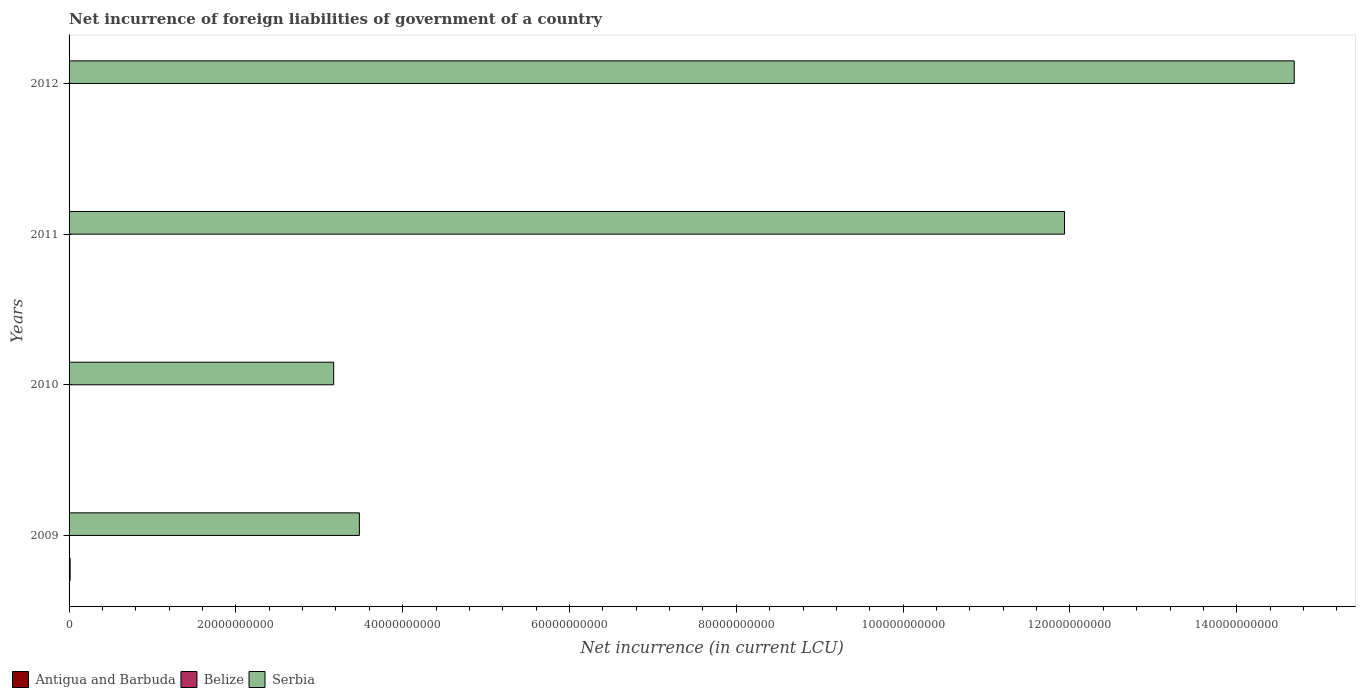How many groups of bars are there?
Your answer should be very brief. 4. Are the number of bars per tick equal to the number of legend labels?
Ensure brevity in your answer.  No. Are the number of bars on each tick of the Y-axis equal?
Ensure brevity in your answer.  No. How many bars are there on the 2nd tick from the bottom?
Keep it short and to the point. 2. What is the net incurrence of foreign liabilities in Antigua and Barbuda in 2009?
Ensure brevity in your answer.  1.27e+08. Across all years, what is the maximum net incurrence of foreign liabilities in Serbia?
Offer a very short reply. 1.47e+11. Across all years, what is the minimum net incurrence of foreign liabilities in Serbia?
Offer a terse response. 3.17e+1. In which year was the net incurrence of foreign liabilities in Serbia maximum?
Your answer should be compact. 2012. What is the total net incurrence of foreign liabilities in Belize in the graph?
Keep it short and to the point. 8.49e+07. What is the difference between the net incurrence of foreign liabilities in Belize in 2009 and that in 2012?
Provide a short and direct response. -2.57e+07. What is the difference between the net incurrence of foreign liabilities in Serbia in 2009 and the net incurrence of foreign liabilities in Antigua and Barbuda in 2011?
Keep it short and to the point. 3.48e+1. What is the average net incurrence of foreign liabilities in Belize per year?
Offer a terse response. 2.12e+07. In the year 2009, what is the difference between the net incurrence of foreign liabilities in Antigua and Barbuda and net incurrence of foreign liabilities in Belize?
Your answer should be very brief. 1.12e+08. What is the ratio of the net incurrence of foreign liabilities in Serbia in 2009 to that in 2012?
Your answer should be compact. 0.24. Is the net incurrence of foreign liabilities in Serbia in 2009 less than that in 2011?
Make the answer very short. Yes. What is the difference between the highest and the second highest net incurrence of foreign liabilities in Belize?
Your answer should be compact. 1.61e+07. What is the difference between the highest and the lowest net incurrence of foreign liabilities in Serbia?
Give a very brief answer. 1.15e+11. Is the sum of the net incurrence of foreign liabilities in Serbia in 2009 and 2012 greater than the maximum net incurrence of foreign liabilities in Antigua and Barbuda across all years?
Your answer should be very brief. Yes. Is it the case that in every year, the sum of the net incurrence of foreign liabilities in Antigua and Barbuda and net incurrence of foreign liabilities in Belize is greater than the net incurrence of foreign liabilities in Serbia?
Your response must be concise. No. What is the difference between two consecutive major ticks on the X-axis?
Offer a very short reply. 2.00e+1. Does the graph contain any zero values?
Provide a succinct answer. Yes. Where does the legend appear in the graph?
Your response must be concise. Bottom left. What is the title of the graph?
Your answer should be compact. Net incurrence of foreign liabilities of government of a country. Does "Sudan" appear as one of the legend labels in the graph?
Offer a terse response. No. What is the label or title of the X-axis?
Offer a very short reply. Net incurrence (in current LCU). What is the label or title of the Y-axis?
Your response must be concise. Years. What is the Net incurrence (in current LCU) of Antigua and Barbuda in 2009?
Provide a short and direct response. 1.27e+08. What is the Net incurrence (in current LCU) of Belize in 2009?
Offer a very short reply. 1.56e+07. What is the Net incurrence (in current LCU) in Serbia in 2009?
Provide a short and direct response. 3.48e+1. What is the Net incurrence (in current LCU) in Antigua and Barbuda in 2010?
Give a very brief answer. 0. What is the Net incurrence (in current LCU) in Belize in 2010?
Keep it short and to the point. 2.74e+06. What is the Net incurrence (in current LCU) of Serbia in 2010?
Offer a terse response. 3.17e+1. What is the Net incurrence (in current LCU) of Antigua and Barbuda in 2011?
Give a very brief answer. 3.81e+07. What is the Net incurrence (in current LCU) in Belize in 2011?
Offer a terse response. 2.52e+07. What is the Net incurrence (in current LCU) in Serbia in 2011?
Offer a very short reply. 1.19e+11. What is the Net incurrence (in current LCU) of Antigua and Barbuda in 2012?
Give a very brief answer. 0. What is the Net incurrence (in current LCU) in Belize in 2012?
Your response must be concise. 4.13e+07. What is the Net incurrence (in current LCU) of Serbia in 2012?
Keep it short and to the point. 1.47e+11. Across all years, what is the maximum Net incurrence (in current LCU) in Antigua and Barbuda?
Make the answer very short. 1.27e+08. Across all years, what is the maximum Net incurrence (in current LCU) of Belize?
Keep it short and to the point. 4.13e+07. Across all years, what is the maximum Net incurrence (in current LCU) in Serbia?
Provide a succinct answer. 1.47e+11. Across all years, what is the minimum Net incurrence (in current LCU) of Belize?
Your answer should be compact. 2.74e+06. Across all years, what is the minimum Net incurrence (in current LCU) of Serbia?
Your response must be concise. 3.17e+1. What is the total Net incurrence (in current LCU) of Antigua and Barbuda in the graph?
Your answer should be compact. 1.65e+08. What is the total Net incurrence (in current LCU) in Belize in the graph?
Provide a short and direct response. 8.49e+07. What is the total Net incurrence (in current LCU) in Serbia in the graph?
Make the answer very short. 3.33e+11. What is the difference between the Net incurrence (in current LCU) of Belize in 2009 and that in 2010?
Provide a short and direct response. 1.29e+07. What is the difference between the Net incurrence (in current LCU) of Serbia in 2009 and that in 2010?
Make the answer very short. 3.08e+09. What is the difference between the Net incurrence (in current LCU) of Antigua and Barbuda in 2009 and that in 2011?
Your response must be concise. 8.92e+07. What is the difference between the Net incurrence (in current LCU) in Belize in 2009 and that in 2011?
Keep it short and to the point. -9.60e+06. What is the difference between the Net incurrence (in current LCU) of Serbia in 2009 and that in 2011?
Make the answer very short. -8.45e+1. What is the difference between the Net incurrence (in current LCU) in Belize in 2009 and that in 2012?
Offer a very short reply. -2.57e+07. What is the difference between the Net incurrence (in current LCU) in Serbia in 2009 and that in 2012?
Provide a succinct answer. -1.12e+11. What is the difference between the Net incurrence (in current LCU) of Belize in 2010 and that in 2011?
Make the answer very short. -2.25e+07. What is the difference between the Net incurrence (in current LCU) of Serbia in 2010 and that in 2011?
Ensure brevity in your answer.  -8.76e+1. What is the difference between the Net incurrence (in current LCU) of Belize in 2010 and that in 2012?
Keep it short and to the point. -3.86e+07. What is the difference between the Net incurrence (in current LCU) in Serbia in 2010 and that in 2012?
Offer a terse response. -1.15e+11. What is the difference between the Net incurrence (in current LCU) in Belize in 2011 and that in 2012?
Make the answer very short. -1.61e+07. What is the difference between the Net incurrence (in current LCU) in Serbia in 2011 and that in 2012?
Provide a succinct answer. -2.75e+1. What is the difference between the Net incurrence (in current LCU) in Antigua and Barbuda in 2009 and the Net incurrence (in current LCU) in Belize in 2010?
Keep it short and to the point. 1.25e+08. What is the difference between the Net incurrence (in current LCU) of Antigua and Barbuda in 2009 and the Net incurrence (in current LCU) of Serbia in 2010?
Offer a very short reply. -3.16e+1. What is the difference between the Net incurrence (in current LCU) in Belize in 2009 and the Net incurrence (in current LCU) in Serbia in 2010?
Make the answer very short. -3.17e+1. What is the difference between the Net incurrence (in current LCU) of Antigua and Barbuda in 2009 and the Net incurrence (in current LCU) of Belize in 2011?
Your response must be concise. 1.02e+08. What is the difference between the Net incurrence (in current LCU) of Antigua and Barbuda in 2009 and the Net incurrence (in current LCU) of Serbia in 2011?
Your response must be concise. -1.19e+11. What is the difference between the Net incurrence (in current LCU) in Belize in 2009 and the Net incurrence (in current LCU) in Serbia in 2011?
Provide a succinct answer. -1.19e+11. What is the difference between the Net incurrence (in current LCU) of Antigua and Barbuda in 2009 and the Net incurrence (in current LCU) of Belize in 2012?
Your response must be concise. 8.60e+07. What is the difference between the Net incurrence (in current LCU) of Antigua and Barbuda in 2009 and the Net incurrence (in current LCU) of Serbia in 2012?
Provide a short and direct response. -1.47e+11. What is the difference between the Net incurrence (in current LCU) of Belize in 2009 and the Net incurrence (in current LCU) of Serbia in 2012?
Make the answer very short. -1.47e+11. What is the difference between the Net incurrence (in current LCU) in Belize in 2010 and the Net incurrence (in current LCU) in Serbia in 2011?
Your response must be concise. -1.19e+11. What is the difference between the Net incurrence (in current LCU) of Belize in 2010 and the Net incurrence (in current LCU) of Serbia in 2012?
Offer a very short reply. -1.47e+11. What is the difference between the Net incurrence (in current LCU) of Antigua and Barbuda in 2011 and the Net incurrence (in current LCU) of Belize in 2012?
Ensure brevity in your answer.  -3.22e+06. What is the difference between the Net incurrence (in current LCU) in Antigua and Barbuda in 2011 and the Net incurrence (in current LCU) in Serbia in 2012?
Make the answer very short. -1.47e+11. What is the difference between the Net incurrence (in current LCU) of Belize in 2011 and the Net incurrence (in current LCU) of Serbia in 2012?
Make the answer very short. -1.47e+11. What is the average Net incurrence (in current LCU) in Antigua and Barbuda per year?
Your response must be concise. 4.14e+07. What is the average Net incurrence (in current LCU) of Belize per year?
Your answer should be compact. 2.12e+07. What is the average Net incurrence (in current LCU) in Serbia per year?
Provide a succinct answer. 8.32e+1. In the year 2009, what is the difference between the Net incurrence (in current LCU) in Antigua and Barbuda and Net incurrence (in current LCU) in Belize?
Provide a succinct answer. 1.12e+08. In the year 2009, what is the difference between the Net incurrence (in current LCU) of Antigua and Barbuda and Net incurrence (in current LCU) of Serbia?
Your answer should be very brief. -3.47e+1. In the year 2009, what is the difference between the Net incurrence (in current LCU) of Belize and Net incurrence (in current LCU) of Serbia?
Offer a terse response. -3.48e+1. In the year 2010, what is the difference between the Net incurrence (in current LCU) in Belize and Net incurrence (in current LCU) in Serbia?
Your response must be concise. -3.17e+1. In the year 2011, what is the difference between the Net incurrence (in current LCU) in Antigua and Barbuda and Net incurrence (in current LCU) in Belize?
Keep it short and to the point. 1.29e+07. In the year 2011, what is the difference between the Net incurrence (in current LCU) of Antigua and Barbuda and Net incurrence (in current LCU) of Serbia?
Make the answer very short. -1.19e+11. In the year 2011, what is the difference between the Net incurrence (in current LCU) in Belize and Net incurrence (in current LCU) in Serbia?
Provide a short and direct response. -1.19e+11. In the year 2012, what is the difference between the Net incurrence (in current LCU) of Belize and Net incurrence (in current LCU) of Serbia?
Keep it short and to the point. -1.47e+11. What is the ratio of the Net incurrence (in current LCU) of Belize in 2009 to that in 2010?
Offer a very short reply. 5.71. What is the ratio of the Net incurrence (in current LCU) of Serbia in 2009 to that in 2010?
Your response must be concise. 1.1. What is the ratio of the Net incurrence (in current LCU) in Antigua and Barbuda in 2009 to that in 2011?
Provide a short and direct response. 3.34. What is the ratio of the Net incurrence (in current LCU) of Belize in 2009 to that in 2011?
Keep it short and to the point. 0.62. What is the ratio of the Net incurrence (in current LCU) of Serbia in 2009 to that in 2011?
Your response must be concise. 0.29. What is the ratio of the Net incurrence (in current LCU) in Belize in 2009 to that in 2012?
Your response must be concise. 0.38. What is the ratio of the Net incurrence (in current LCU) of Serbia in 2009 to that in 2012?
Provide a short and direct response. 0.24. What is the ratio of the Net incurrence (in current LCU) of Belize in 2010 to that in 2011?
Your response must be concise. 0.11. What is the ratio of the Net incurrence (in current LCU) in Serbia in 2010 to that in 2011?
Provide a succinct answer. 0.27. What is the ratio of the Net incurrence (in current LCU) of Belize in 2010 to that in 2012?
Offer a terse response. 0.07. What is the ratio of the Net incurrence (in current LCU) of Serbia in 2010 to that in 2012?
Your response must be concise. 0.22. What is the ratio of the Net incurrence (in current LCU) in Belize in 2011 to that in 2012?
Make the answer very short. 0.61. What is the ratio of the Net incurrence (in current LCU) in Serbia in 2011 to that in 2012?
Offer a terse response. 0.81. What is the difference between the highest and the second highest Net incurrence (in current LCU) in Belize?
Provide a succinct answer. 1.61e+07. What is the difference between the highest and the second highest Net incurrence (in current LCU) in Serbia?
Provide a short and direct response. 2.75e+1. What is the difference between the highest and the lowest Net incurrence (in current LCU) of Antigua and Barbuda?
Offer a very short reply. 1.27e+08. What is the difference between the highest and the lowest Net incurrence (in current LCU) in Belize?
Provide a short and direct response. 3.86e+07. What is the difference between the highest and the lowest Net incurrence (in current LCU) of Serbia?
Your answer should be compact. 1.15e+11. 